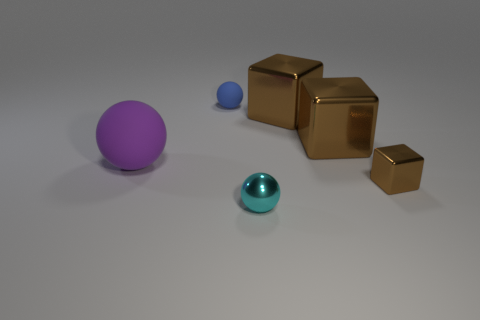Are there fewer purple balls than big purple shiny cylinders?
Your answer should be very brief. No. There is a ball that is behind the tiny brown block and in front of the tiny blue object; what size is it?
Ensure brevity in your answer.  Large. Does the metallic cube that is in front of the large purple sphere have the same color as the small rubber thing?
Provide a succinct answer. No. Are there fewer tiny cyan metallic balls that are behind the purple matte ball than small objects?
Ensure brevity in your answer.  Yes. There is a thing that is made of the same material as the purple sphere; what shape is it?
Offer a terse response. Sphere. Are the big purple thing and the blue ball made of the same material?
Provide a succinct answer. Yes. Is the number of small blue rubber objects behind the blue matte sphere less than the number of small blue balls that are in front of the big purple ball?
Ensure brevity in your answer.  No. There is a tiny ball in front of the sphere behind the purple matte thing; what number of large rubber balls are to the right of it?
Ensure brevity in your answer.  0. Is the color of the big rubber sphere the same as the small rubber thing?
Your answer should be compact. No. Are there any metallic spheres that have the same color as the big matte object?
Your answer should be compact. No. 